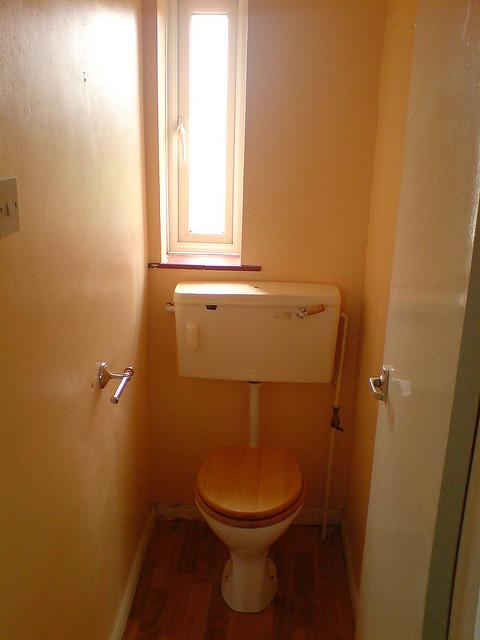What room is this?
Keep it brief. Bathroom. Is the light on?
Give a very brief answer. No. Is the toilet seat covered with plastic?
Give a very brief answer. No. What is illuminating the room?
Be succinct. Window. Is this an American bathroom?
Give a very brief answer. No. Does this door have a lever style knob?
Quick response, please. Yes. Is there a window in this picture?
Give a very brief answer. Yes. What color is the bathroom wall?
Answer briefly. Yellow. 